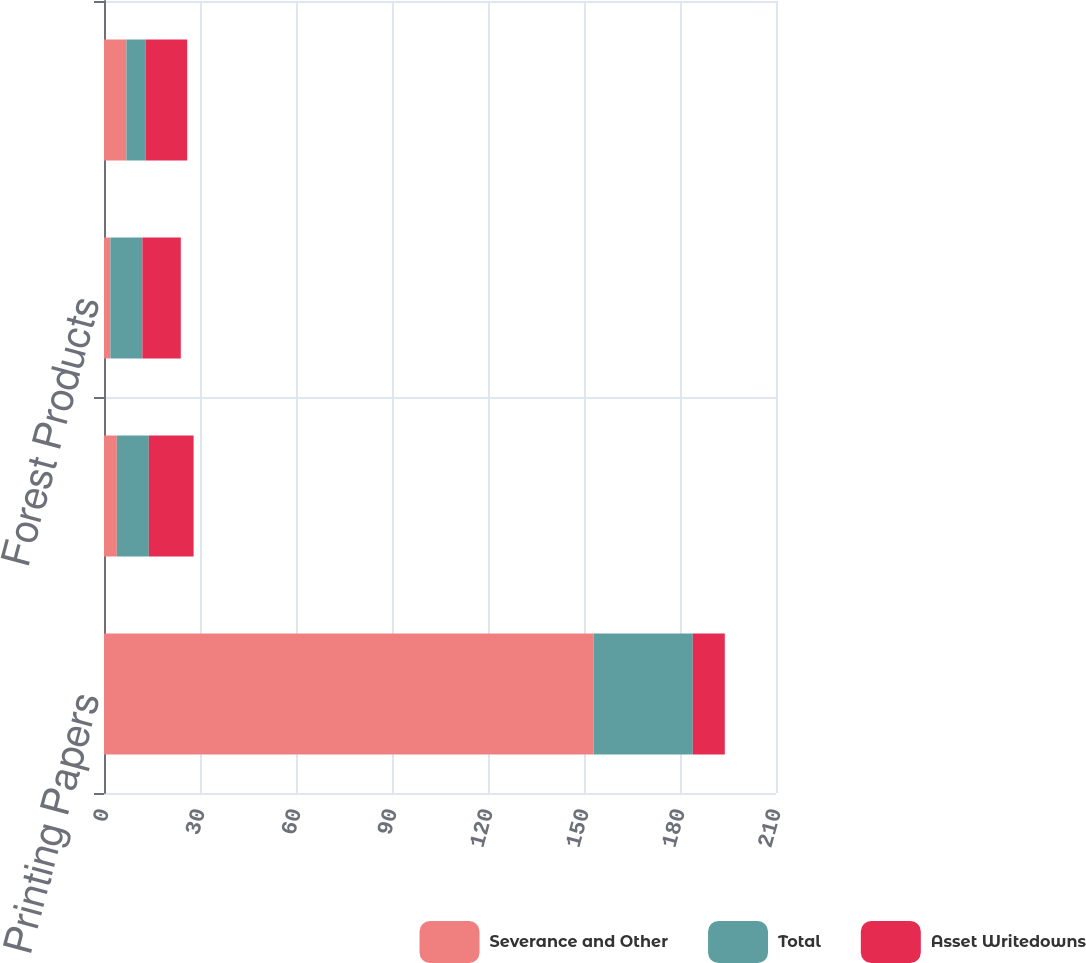Convert chart. <chart><loc_0><loc_0><loc_500><loc_500><stacked_bar_chart><ecel><fcel>Printing Papers<fcel>Industrial Packaging<fcel>Forest Products<fcel>Specialty Businesses and Other<nl><fcel>Severance and Other<fcel>153<fcel>4<fcel>2<fcel>7<nl><fcel>Total<fcel>31<fcel>10<fcel>10<fcel>6<nl><fcel>Asset Writedowns<fcel>10<fcel>14<fcel>12<fcel>13<nl></chart> 